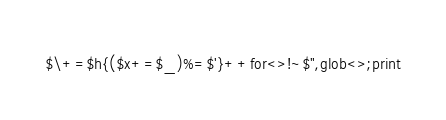<code> <loc_0><loc_0><loc_500><loc_500><_Perl_>$\+=$h{($x+=$_)%=$'}++for<>!~$",glob<>;print</code> 